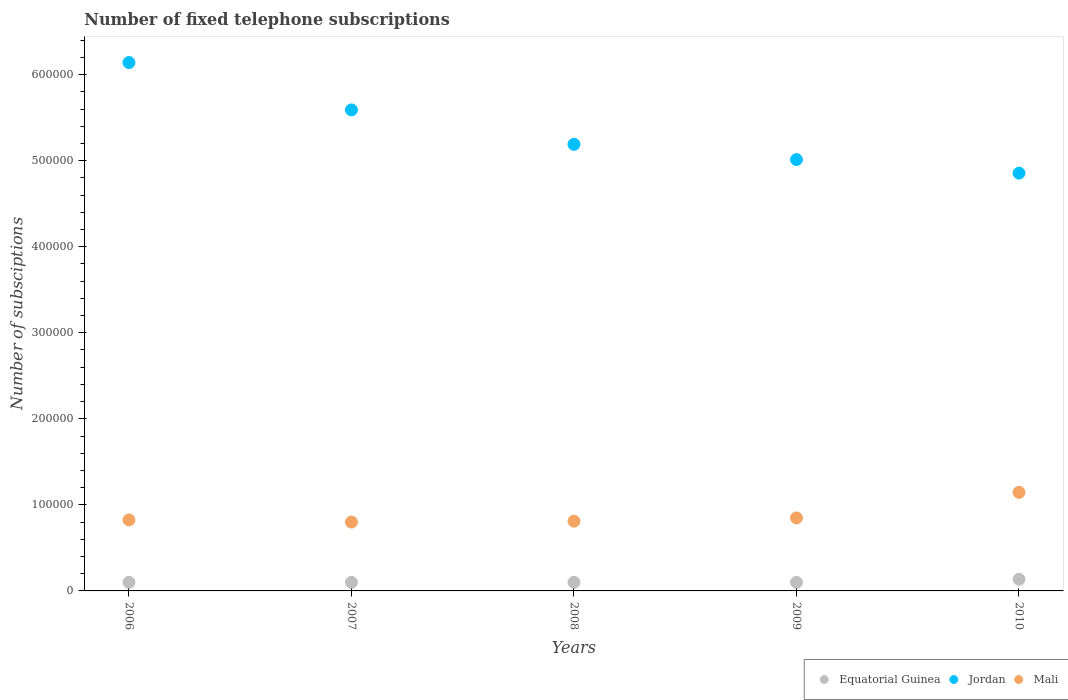How many different coloured dotlines are there?
Offer a very short reply. 3. Is the number of dotlines equal to the number of legend labels?
Your answer should be very brief. Yes. What is the number of fixed telephone subscriptions in Equatorial Guinea in 2010?
Provide a succinct answer. 1.35e+04. Across all years, what is the maximum number of fixed telephone subscriptions in Mali?
Ensure brevity in your answer.  1.15e+05. Across all years, what is the minimum number of fixed telephone subscriptions in Jordan?
Give a very brief answer. 4.86e+05. What is the total number of fixed telephone subscriptions in Equatorial Guinea in the graph?
Ensure brevity in your answer.  5.35e+04. What is the difference between the number of fixed telephone subscriptions in Mali in 2006 and the number of fixed telephone subscriptions in Jordan in 2009?
Your response must be concise. -4.19e+05. What is the average number of fixed telephone subscriptions in Mali per year?
Provide a succinct answer. 8.86e+04. In the year 2009, what is the difference between the number of fixed telephone subscriptions in Equatorial Guinea and number of fixed telephone subscriptions in Jordan?
Your response must be concise. -4.91e+05. In how many years, is the number of fixed telephone subscriptions in Mali greater than 80000?
Your answer should be very brief. 5. What is the ratio of the number of fixed telephone subscriptions in Equatorial Guinea in 2006 to that in 2007?
Provide a short and direct response. 1. Is the difference between the number of fixed telephone subscriptions in Equatorial Guinea in 2006 and 2008 greater than the difference between the number of fixed telephone subscriptions in Jordan in 2006 and 2008?
Your response must be concise. No. What is the difference between the highest and the second highest number of fixed telephone subscriptions in Jordan?
Provide a succinct answer. 5.50e+04. What is the difference between the highest and the lowest number of fixed telephone subscriptions in Mali?
Ensure brevity in your answer.  3.45e+04. In how many years, is the number of fixed telephone subscriptions in Mali greater than the average number of fixed telephone subscriptions in Mali taken over all years?
Your response must be concise. 1. Does the number of fixed telephone subscriptions in Equatorial Guinea monotonically increase over the years?
Your answer should be compact. No. Is the number of fixed telephone subscriptions in Equatorial Guinea strictly greater than the number of fixed telephone subscriptions in Mali over the years?
Your response must be concise. No. Is the number of fixed telephone subscriptions in Mali strictly less than the number of fixed telephone subscriptions in Jordan over the years?
Provide a succinct answer. Yes. How many dotlines are there?
Keep it short and to the point. 3. Are the values on the major ticks of Y-axis written in scientific E-notation?
Provide a short and direct response. No. Does the graph contain any zero values?
Give a very brief answer. No. Where does the legend appear in the graph?
Keep it short and to the point. Bottom right. How many legend labels are there?
Offer a terse response. 3. How are the legend labels stacked?
Provide a succinct answer. Horizontal. What is the title of the graph?
Provide a succinct answer. Number of fixed telephone subscriptions. Does "West Bank and Gaza" appear as one of the legend labels in the graph?
Ensure brevity in your answer.  No. What is the label or title of the Y-axis?
Ensure brevity in your answer.  Number of subsciptions. What is the Number of subsciptions of Equatorial Guinea in 2006?
Ensure brevity in your answer.  10000. What is the Number of subsciptions in Jordan in 2006?
Your response must be concise. 6.14e+05. What is the Number of subsciptions of Mali in 2006?
Your answer should be compact. 8.25e+04. What is the Number of subsciptions in Jordan in 2007?
Ensure brevity in your answer.  5.59e+05. What is the Number of subsciptions in Mali in 2007?
Make the answer very short. 8.00e+04. What is the Number of subsciptions of Equatorial Guinea in 2008?
Your answer should be compact. 10000. What is the Number of subsciptions in Jordan in 2008?
Your answer should be very brief. 5.19e+05. What is the Number of subsciptions of Mali in 2008?
Your answer should be compact. 8.11e+04. What is the Number of subsciptions of Equatorial Guinea in 2009?
Your answer should be compact. 10000. What is the Number of subsciptions of Jordan in 2009?
Provide a short and direct response. 5.01e+05. What is the Number of subsciptions in Mali in 2009?
Ensure brevity in your answer.  8.48e+04. What is the Number of subsciptions in Equatorial Guinea in 2010?
Your answer should be very brief. 1.35e+04. What is the Number of subsciptions of Jordan in 2010?
Keep it short and to the point. 4.86e+05. What is the Number of subsciptions of Mali in 2010?
Your response must be concise. 1.15e+05. Across all years, what is the maximum Number of subsciptions of Equatorial Guinea?
Offer a very short reply. 1.35e+04. Across all years, what is the maximum Number of subsciptions in Jordan?
Your answer should be very brief. 6.14e+05. Across all years, what is the maximum Number of subsciptions of Mali?
Give a very brief answer. 1.15e+05. Across all years, what is the minimum Number of subsciptions in Equatorial Guinea?
Your answer should be very brief. 10000. Across all years, what is the minimum Number of subsciptions in Jordan?
Give a very brief answer. 4.86e+05. Across all years, what is the minimum Number of subsciptions in Mali?
Provide a succinct answer. 8.00e+04. What is the total Number of subsciptions in Equatorial Guinea in the graph?
Provide a short and direct response. 5.35e+04. What is the total Number of subsciptions of Jordan in the graph?
Offer a very short reply. 2.68e+06. What is the total Number of subsciptions in Mali in the graph?
Provide a succinct answer. 4.43e+05. What is the difference between the Number of subsciptions in Jordan in 2006 and that in 2007?
Offer a very short reply. 5.50e+04. What is the difference between the Number of subsciptions of Mali in 2006 and that in 2007?
Your answer should be very brief. 2516. What is the difference between the Number of subsciptions of Equatorial Guinea in 2006 and that in 2008?
Keep it short and to the point. 0. What is the difference between the Number of subsciptions in Jordan in 2006 and that in 2008?
Your response must be concise. 9.50e+04. What is the difference between the Number of subsciptions of Mali in 2006 and that in 2008?
Offer a very short reply. 1445. What is the difference between the Number of subsciptions in Jordan in 2006 and that in 2009?
Keep it short and to the point. 1.13e+05. What is the difference between the Number of subsciptions in Mali in 2006 and that in 2009?
Give a very brief answer. -2275. What is the difference between the Number of subsciptions of Equatorial Guinea in 2006 and that in 2010?
Offer a terse response. -3537. What is the difference between the Number of subsciptions in Jordan in 2006 and that in 2010?
Keep it short and to the point. 1.28e+05. What is the difference between the Number of subsciptions of Mali in 2006 and that in 2010?
Ensure brevity in your answer.  -3.20e+04. What is the difference between the Number of subsciptions of Jordan in 2007 and that in 2008?
Provide a short and direct response. 4.00e+04. What is the difference between the Number of subsciptions of Mali in 2007 and that in 2008?
Offer a very short reply. -1071. What is the difference between the Number of subsciptions of Equatorial Guinea in 2007 and that in 2009?
Keep it short and to the point. 0. What is the difference between the Number of subsciptions in Jordan in 2007 and that in 2009?
Your answer should be compact. 5.78e+04. What is the difference between the Number of subsciptions of Mali in 2007 and that in 2009?
Your answer should be very brief. -4791. What is the difference between the Number of subsciptions of Equatorial Guinea in 2007 and that in 2010?
Your answer should be compact. -3537. What is the difference between the Number of subsciptions of Jordan in 2007 and that in 2010?
Make the answer very short. 7.35e+04. What is the difference between the Number of subsciptions in Mali in 2007 and that in 2010?
Provide a succinct answer. -3.45e+04. What is the difference between the Number of subsciptions in Jordan in 2008 and that in 2009?
Make the answer very short. 1.78e+04. What is the difference between the Number of subsciptions of Mali in 2008 and that in 2009?
Offer a terse response. -3720. What is the difference between the Number of subsciptions in Equatorial Guinea in 2008 and that in 2010?
Offer a very short reply. -3537. What is the difference between the Number of subsciptions of Jordan in 2008 and that in 2010?
Your answer should be compact. 3.35e+04. What is the difference between the Number of subsciptions of Mali in 2008 and that in 2010?
Give a very brief answer. -3.35e+04. What is the difference between the Number of subsciptions of Equatorial Guinea in 2009 and that in 2010?
Make the answer very short. -3537. What is the difference between the Number of subsciptions of Jordan in 2009 and that in 2010?
Your response must be concise. 1.57e+04. What is the difference between the Number of subsciptions of Mali in 2009 and that in 2010?
Keep it short and to the point. -2.98e+04. What is the difference between the Number of subsciptions in Equatorial Guinea in 2006 and the Number of subsciptions in Jordan in 2007?
Offer a very short reply. -5.49e+05. What is the difference between the Number of subsciptions in Equatorial Guinea in 2006 and the Number of subsciptions in Mali in 2007?
Give a very brief answer. -7.00e+04. What is the difference between the Number of subsciptions of Jordan in 2006 and the Number of subsciptions of Mali in 2007?
Ensure brevity in your answer.  5.34e+05. What is the difference between the Number of subsciptions in Equatorial Guinea in 2006 and the Number of subsciptions in Jordan in 2008?
Keep it short and to the point. -5.09e+05. What is the difference between the Number of subsciptions of Equatorial Guinea in 2006 and the Number of subsciptions of Mali in 2008?
Offer a very short reply. -7.11e+04. What is the difference between the Number of subsciptions in Jordan in 2006 and the Number of subsciptions in Mali in 2008?
Offer a very short reply. 5.33e+05. What is the difference between the Number of subsciptions in Equatorial Guinea in 2006 and the Number of subsciptions in Jordan in 2009?
Your response must be concise. -4.91e+05. What is the difference between the Number of subsciptions in Equatorial Guinea in 2006 and the Number of subsciptions in Mali in 2009?
Make the answer very short. -7.48e+04. What is the difference between the Number of subsciptions in Jordan in 2006 and the Number of subsciptions in Mali in 2009?
Provide a short and direct response. 5.29e+05. What is the difference between the Number of subsciptions in Equatorial Guinea in 2006 and the Number of subsciptions in Jordan in 2010?
Ensure brevity in your answer.  -4.76e+05. What is the difference between the Number of subsciptions in Equatorial Guinea in 2006 and the Number of subsciptions in Mali in 2010?
Your response must be concise. -1.05e+05. What is the difference between the Number of subsciptions in Jordan in 2006 and the Number of subsciptions in Mali in 2010?
Your answer should be very brief. 4.99e+05. What is the difference between the Number of subsciptions of Equatorial Guinea in 2007 and the Number of subsciptions of Jordan in 2008?
Provide a succinct answer. -5.09e+05. What is the difference between the Number of subsciptions in Equatorial Guinea in 2007 and the Number of subsciptions in Mali in 2008?
Provide a succinct answer. -7.11e+04. What is the difference between the Number of subsciptions in Jordan in 2007 and the Number of subsciptions in Mali in 2008?
Make the answer very short. 4.78e+05. What is the difference between the Number of subsciptions of Equatorial Guinea in 2007 and the Number of subsciptions of Jordan in 2009?
Offer a very short reply. -4.91e+05. What is the difference between the Number of subsciptions in Equatorial Guinea in 2007 and the Number of subsciptions in Mali in 2009?
Offer a terse response. -7.48e+04. What is the difference between the Number of subsciptions of Jordan in 2007 and the Number of subsciptions of Mali in 2009?
Your answer should be compact. 4.74e+05. What is the difference between the Number of subsciptions of Equatorial Guinea in 2007 and the Number of subsciptions of Jordan in 2010?
Your answer should be compact. -4.76e+05. What is the difference between the Number of subsciptions in Equatorial Guinea in 2007 and the Number of subsciptions in Mali in 2010?
Give a very brief answer. -1.05e+05. What is the difference between the Number of subsciptions in Jordan in 2007 and the Number of subsciptions in Mali in 2010?
Offer a terse response. 4.44e+05. What is the difference between the Number of subsciptions of Equatorial Guinea in 2008 and the Number of subsciptions of Jordan in 2009?
Your answer should be very brief. -4.91e+05. What is the difference between the Number of subsciptions of Equatorial Guinea in 2008 and the Number of subsciptions of Mali in 2009?
Make the answer very short. -7.48e+04. What is the difference between the Number of subsciptions in Jordan in 2008 and the Number of subsciptions in Mali in 2009?
Ensure brevity in your answer.  4.34e+05. What is the difference between the Number of subsciptions in Equatorial Guinea in 2008 and the Number of subsciptions in Jordan in 2010?
Provide a succinct answer. -4.76e+05. What is the difference between the Number of subsciptions in Equatorial Guinea in 2008 and the Number of subsciptions in Mali in 2010?
Provide a short and direct response. -1.05e+05. What is the difference between the Number of subsciptions in Jordan in 2008 and the Number of subsciptions in Mali in 2010?
Keep it short and to the point. 4.04e+05. What is the difference between the Number of subsciptions of Equatorial Guinea in 2009 and the Number of subsciptions of Jordan in 2010?
Your answer should be very brief. -4.76e+05. What is the difference between the Number of subsciptions of Equatorial Guinea in 2009 and the Number of subsciptions of Mali in 2010?
Give a very brief answer. -1.05e+05. What is the difference between the Number of subsciptions of Jordan in 2009 and the Number of subsciptions of Mali in 2010?
Make the answer very short. 3.87e+05. What is the average Number of subsciptions in Equatorial Guinea per year?
Give a very brief answer. 1.07e+04. What is the average Number of subsciptions of Jordan per year?
Offer a terse response. 5.36e+05. What is the average Number of subsciptions in Mali per year?
Offer a very short reply. 8.86e+04. In the year 2006, what is the difference between the Number of subsciptions in Equatorial Guinea and Number of subsciptions in Jordan?
Offer a very short reply. -6.04e+05. In the year 2006, what is the difference between the Number of subsciptions of Equatorial Guinea and Number of subsciptions of Mali?
Give a very brief answer. -7.25e+04. In the year 2006, what is the difference between the Number of subsciptions of Jordan and Number of subsciptions of Mali?
Your answer should be compact. 5.31e+05. In the year 2007, what is the difference between the Number of subsciptions in Equatorial Guinea and Number of subsciptions in Jordan?
Keep it short and to the point. -5.49e+05. In the year 2007, what is the difference between the Number of subsciptions of Equatorial Guinea and Number of subsciptions of Mali?
Give a very brief answer. -7.00e+04. In the year 2007, what is the difference between the Number of subsciptions in Jordan and Number of subsciptions in Mali?
Offer a terse response. 4.79e+05. In the year 2008, what is the difference between the Number of subsciptions in Equatorial Guinea and Number of subsciptions in Jordan?
Make the answer very short. -5.09e+05. In the year 2008, what is the difference between the Number of subsciptions in Equatorial Guinea and Number of subsciptions in Mali?
Provide a short and direct response. -7.11e+04. In the year 2008, what is the difference between the Number of subsciptions of Jordan and Number of subsciptions of Mali?
Make the answer very short. 4.38e+05. In the year 2009, what is the difference between the Number of subsciptions of Equatorial Guinea and Number of subsciptions of Jordan?
Make the answer very short. -4.91e+05. In the year 2009, what is the difference between the Number of subsciptions of Equatorial Guinea and Number of subsciptions of Mali?
Give a very brief answer. -7.48e+04. In the year 2009, what is the difference between the Number of subsciptions of Jordan and Number of subsciptions of Mali?
Provide a succinct answer. 4.16e+05. In the year 2010, what is the difference between the Number of subsciptions in Equatorial Guinea and Number of subsciptions in Jordan?
Give a very brief answer. -4.72e+05. In the year 2010, what is the difference between the Number of subsciptions of Equatorial Guinea and Number of subsciptions of Mali?
Make the answer very short. -1.01e+05. In the year 2010, what is the difference between the Number of subsciptions of Jordan and Number of subsciptions of Mali?
Make the answer very short. 3.71e+05. What is the ratio of the Number of subsciptions of Equatorial Guinea in 2006 to that in 2007?
Offer a terse response. 1. What is the ratio of the Number of subsciptions in Jordan in 2006 to that in 2007?
Offer a very short reply. 1.1. What is the ratio of the Number of subsciptions of Mali in 2006 to that in 2007?
Provide a succinct answer. 1.03. What is the ratio of the Number of subsciptions of Jordan in 2006 to that in 2008?
Your response must be concise. 1.18. What is the ratio of the Number of subsciptions in Mali in 2006 to that in 2008?
Make the answer very short. 1.02. What is the ratio of the Number of subsciptions of Equatorial Guinea in 2006 to that in 2009?
Your answer should be very brief. 1. What is the ratio of the Number of subsciptions of Jordan in 2006 to that in 2009?
Offer a very short reply. 1.23. What is the ratio of the Number of subsciptions of Mali in 2006 to that in 2009?
Give a very brief answer. 0.97. What is the ratio of the Number of subsciptions of Equatorial Guinea in 2006 to that in 2010?
Offer a terse response. 0.74. What is the ratio of the Number of subsciptions of Jordan in 2006 to that in 2010?
Your answer should be very brief. 1.26. What is the ratio of the Number of subsciptions of Mali in 2006 to that in 2010?
Your response must be concise. 0.72. What is the ratio of the Number of subsciptions of Jordan in 2007 to that in 2008?
Your answer should be compact. 1.08. What is the ratio of the Number of subsciptions of Mali in 2007 to that in 2008?
Your answer should be very brief. 0.99. What is the ratio of the Number of subsciptions in Equatorial Guinea in 2007 to that in 2009?
Make the answer very short. 1. What is the ratio of the Number of subsciptions in Jordan in 2007 to that in 2009?
Ensure brevity in your answer.  1.12. What is the ratio of the Number of subsciptions of Mali in 2007 to that in 2009?
Offer a very short reply. 0.94. What is the ratio of the Number of subsciptions of Equatorial Guinea in 2007 to that in 2010?
Make the answer very short. 0.74. What is the ratio of the Number of subsciptions of Jordan in 2007 to that in 2010?
Offer a terse response. 1.15. What is the ratio of the Number of subsciptions in Mali in 2007 to that in 2010?
Your answer should be compact. 0.7. What is the ratio of the Number of subsciptions of Jordan in 2008 to that in 2009?
Offer a terse response. 1.04. What is the ratio of the Number of subsciptions in Mali in 2008 to that in 2009?
Give a very brief answer. 0.96. What is the ratio of the Number of subsciptions of Equatorial Guinea in 2008 to that in 2010?
Your answer should be very brief. 0.74. What is the ratio of the Number of subsciptions of Jordan in 2008 to that in 2010?
Keep it short and to the point. 1.07. What is the ratio of the Number of subsciptions of Mali in 2008 to that in 2010?
Your answer should be very brief. 0.71. What is the ratio of the Number of subsciptions in Equatorial Guinea in 2009 to that in 2010?
Offer a very short reply. 0.74. What is the ratio of the Number of subsciptions in Jordan in 2009 to that in 2010?
Give a very brief answer. 1.03. What is the ratio of the Number of subsciptions in Mali in 2009 to that in 2010?
Provide a succinct answer. 0.74. What is the difference between the highest and the second highest Number of subsciptions of Equatorial Guinea?
Offer a very short reply. 3537. What is the difference between the highest and the second highest Number of subsciptions in Jordan?
Your answer should be very brief. 5.50e+04. What is the difference between the highest and the second highest Number of subsciptions of Mali?
Ensure brevity in your answer.  2.98e+04. What is the difference between the highest and the lowest Number of subsciptions of Equatorial Guinea?
Give a very brief answer. 3537. What is the difference between the highest and the lowest Number of subsciptions in Jordan?
Make the answer very short. 1.28e+05. What is the difference between the highest and the lowest Number of subsciptions in Mali?
Ensure brevity in your answer.  3.45e+04. 